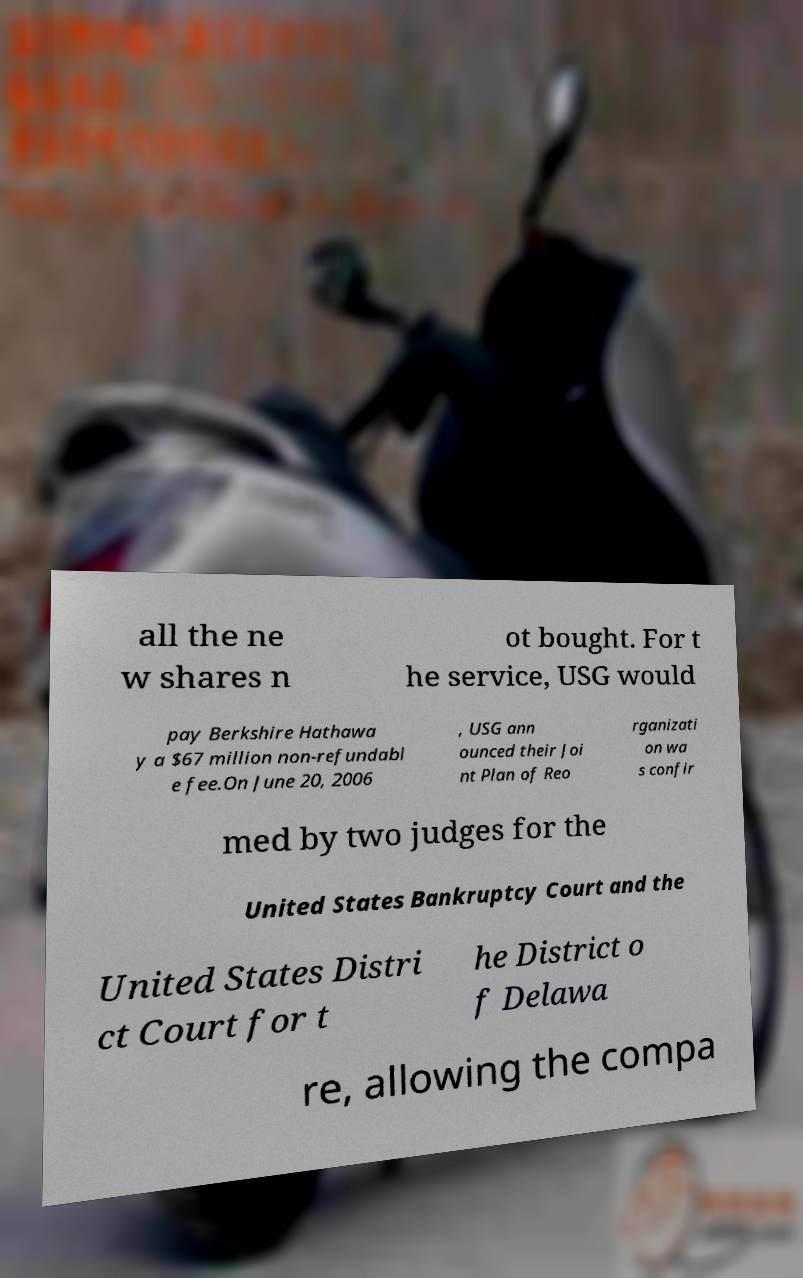Could you extract and type out the text from this image? all the ne w shares n ot bought. For t he service, USG would pay Berkshire Hathawa y a $67 million non-refundabl e fee.On June 20, 2006 , USG ann ounced their Joi nt Plan of Reo rganizati on wa s confir med by two judges for the United States Bankruptcy Court and the United States Distri ct Court for t he District o f Delawa re, allowing the compa 